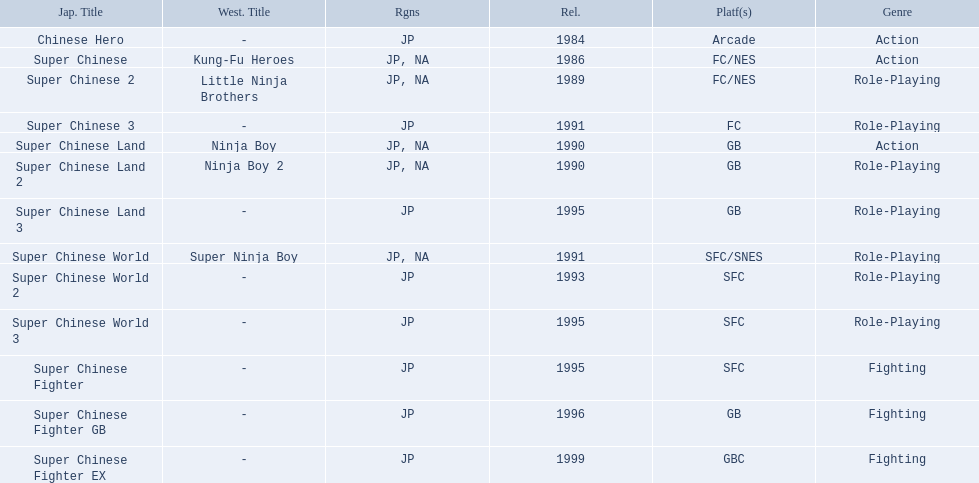What japanese titles were released in the north american (na) region? Super Chinese, Super Chinese 2, Super Chinese Land, Super Chinese Land 2, Super Chinese World. Of those, which one was released most recently? Super Chinese World. Would you mind parsing the complete table? {'header': ['Jap. Title', 'West. Title', 'Rgns', 'Rel.', 'Platf(s)', 'Genre'], 'rows': [['Chinese Hero', '-', 'JP', '1984', 'Arcade', 'Action'], ['Super Chinese', 'Kung-Fu Heroes', 'JP, NA', '1986', 'FC/NES', 'Action'], ['Super Chinese 2', 'Little Ninja Brothers', 'JP, NA', '1989', 'FC/NES', 'Role-Playing'], ['Super Chinese 3', '-', 'JP', '1991', 'FC', 'Role-Playing'], ['Super Chinese Land', 'Ninja Boy', 'JP, NA', '1990', 'GB', 'Action'], ['Super Chinese Land 2', 'Ninja Boy 2', 'JP, NA', '1990', 'GB', 'Role-Playing'], ['Super Chinese Land 3', '-', 'JP', '1995', 'GB', 'Role-Playing'], ['Super Chinese World', 'Super Ninja Boy', 'JP, NA', '1991', 'SFC/SNES', 'Role-Playing'], ['Super Chinese World 2', '-', 'JP', '1993', 'SFC', 'Role-Playing'], ['Super Chinese World 3', '-', 'JP', '1995', 'SFC', 'Role-Playing'], ['Super Chinese Fighter', '-', 'JP', '1995', 'SFC', 'Fighting'], ['Super Chinese Fighter GB', '-', 'JP', '1996', 'GB', 'Fighting'], ['Super Chinese Fighter EX', '-', 'JP', '1999', 'GBC', 'Fighting']]} 